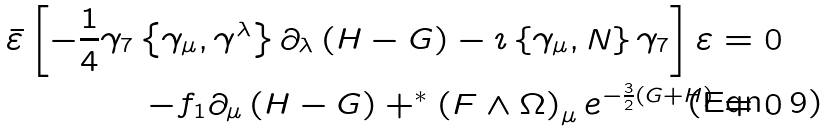Convert formula to latex. <formula><loc_0><loc_0><loc_500><loc_500>\bar { \varepsilon } \left [ - \frac { 1 } { 4 } \gamma _ { 7 } \left \{ \gamma _ { \mu } , \gamma ^ { \lambda } \right \} \partial _ { \lambda } \left ( H - G \right ) - \imath \left \{ \gamma _ { \mu } , N \right \} \gamma _ { 7 } \right ] \varepsilon & = 0 \\ - f _ { 1 } \partial _ { \mu } \left ( H - G \right ) + ^ { * } \left ( F \wedge \Omega \right ) _ { \mu } e ^ { - \frac { 3 } { 2 } \left ( G + H \right ) } & = 0</formula> 